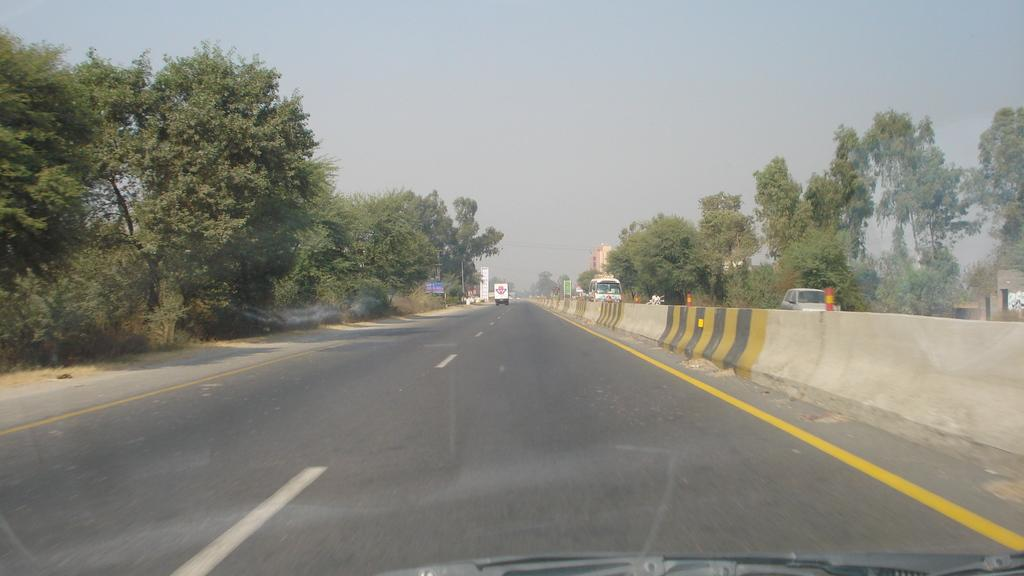What is the main feature in the middle of the image? There is a road in the middle of the image. What can be seen on either side of the road? There are trees on either side of the road. What type of vehicle is visible on the road? A bus is coming towards the opposite direction on the road. What is visible at the top of the image? The sky is visible at the top of the image. How many dogs are sitting on the bus in the image? There are no dogs present in the image, and the bus does not have any visible passengers. 